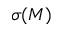Convert formula to latex. <formula><loc_0><loc_0><loc_500><loc_500>\sigma ( M )</formula> 